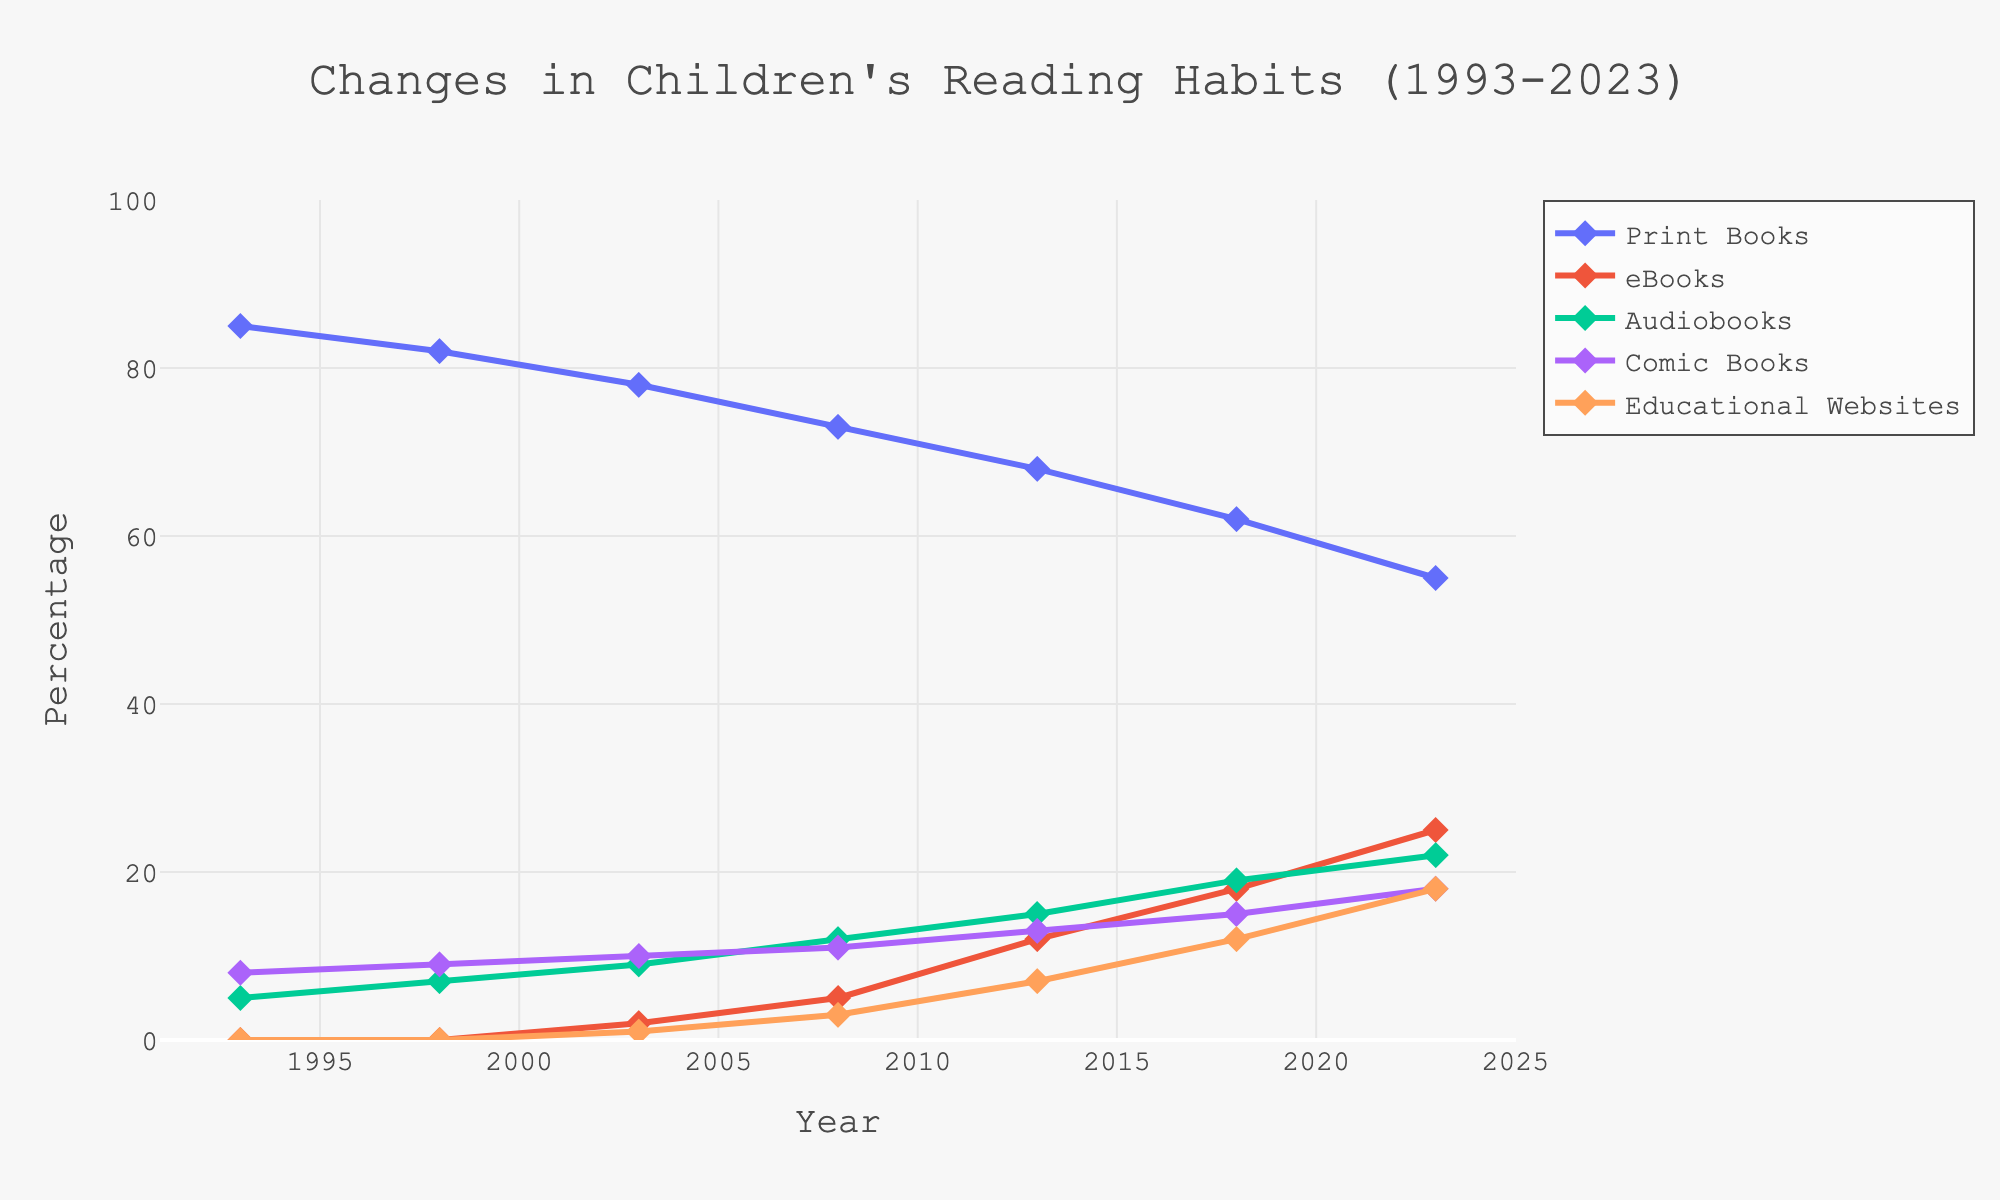Which reading habit has shown the greatest decrease in percentage over the 30 years? To find the habit with the greatest decrease, look at the 1993 and 2023 values for each habit and calculate the difference. Print Books decrease from 85% to 55%, which is a 30% decrease.
Answer: Print Books Which reading habit had the highest growth rate between 1993 and 2023? Calculate the increase for each habit percentage-wise from 1993 to 2023. eBooks increased from 0% to 25% (25% increase), and Educational Websites from 0% to 18% (18% increase). The highest increase is for eBooks.
Answer: eBooks Are audiobooks or comic books more popular in 2023? Compare the 2023 percentages for Audiobooks (22%) and Comic Books (18%). Audiobooks have a higher percentage.
Answer: Audiobooks What's the average percentage for eBooks over the years provided? Sum the percentages for eBooks across the years: 0, 0, 2, 5, 12, 18, 25. The sum is 62. Divide by 7 (number of years): 62 / 7 = 8.86%.
Answer: 8.86% Which reading habit had the lowest percentage in 2013? Compare the 2013 percentages for each habit: Print Books (68%), eBooks (12%), Audiobooks (15%), Comic Books (13%), Educational Websites (7%). The lowest is Educational Websites.
Answer: Educational Websites How many habits had at least 15% popularity in 2023? Check how many habits in 2023 have percentages ≥ 15%: Print Books (55%), eBooks (25%), Audiobooks (22%), Comic Books (18%), Educational Websites (18%). All five habits meet this criterion.
Answer: 5 habits By how much did the popularity of Comic Books change from 1993 to 2023? Find the difference between the 2023 and 1993 percentages for Comic Books: 18% - 8% = 10%.
Answer: 10% In which year did Print Books first drop below 70%? Check the values for Print Books over the years. It dropped below 70% in 2013 when it became 68%.
Answer: 2013 Compare the popularity of Print Books and eBooks in 2018. Which is higher? In 2018, Print Books was at 62% and eBooks at 18%. Print Books has a higher percentage.
Answer: Print Books What is the total percentage change for Audiobooks from 1993 to 2023? Calculate the percentage change: 2023 (22%) - 1993 (5%) = 17%.
Answer: 17% 